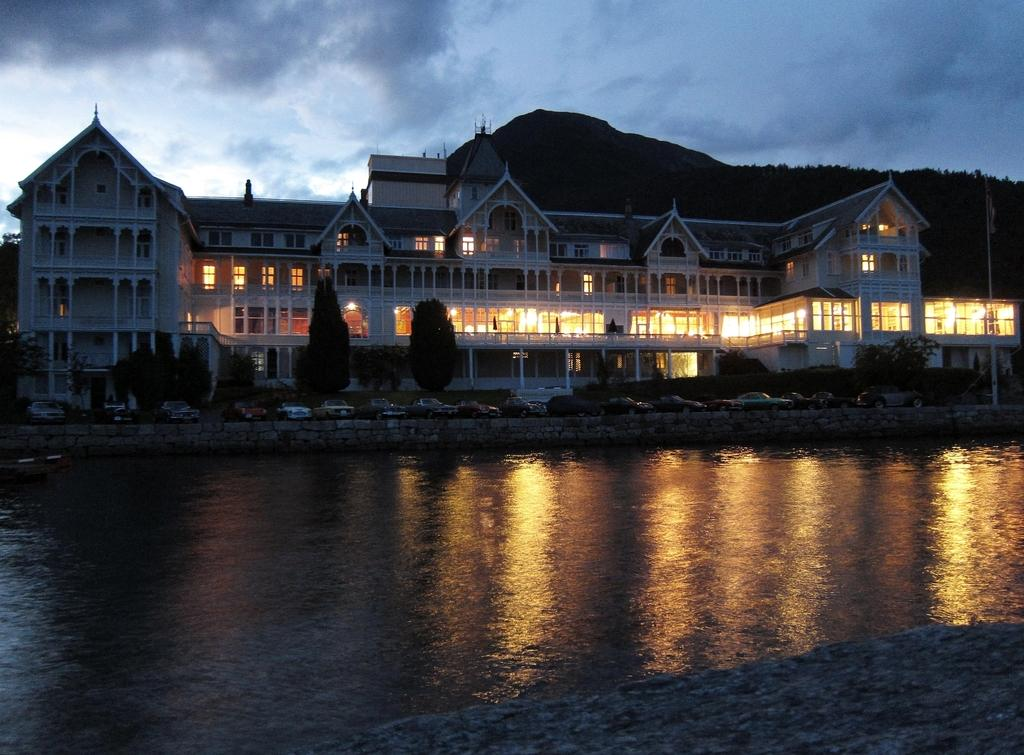What is in the foreground of the image? There is a water body in the foreground of the image. What can be seen in the background of the image? There are cars parked in the background of the image, and they are in front of a building. What other elements are present in the background of the image? There are trees and hills in the background of the image. How would you describe the sky in the image? The sky is cloudy in the image. How many animals are visible in the image? There are no animals visible in the image. Are there any sheep in the image? There are no sheep present in the image. 